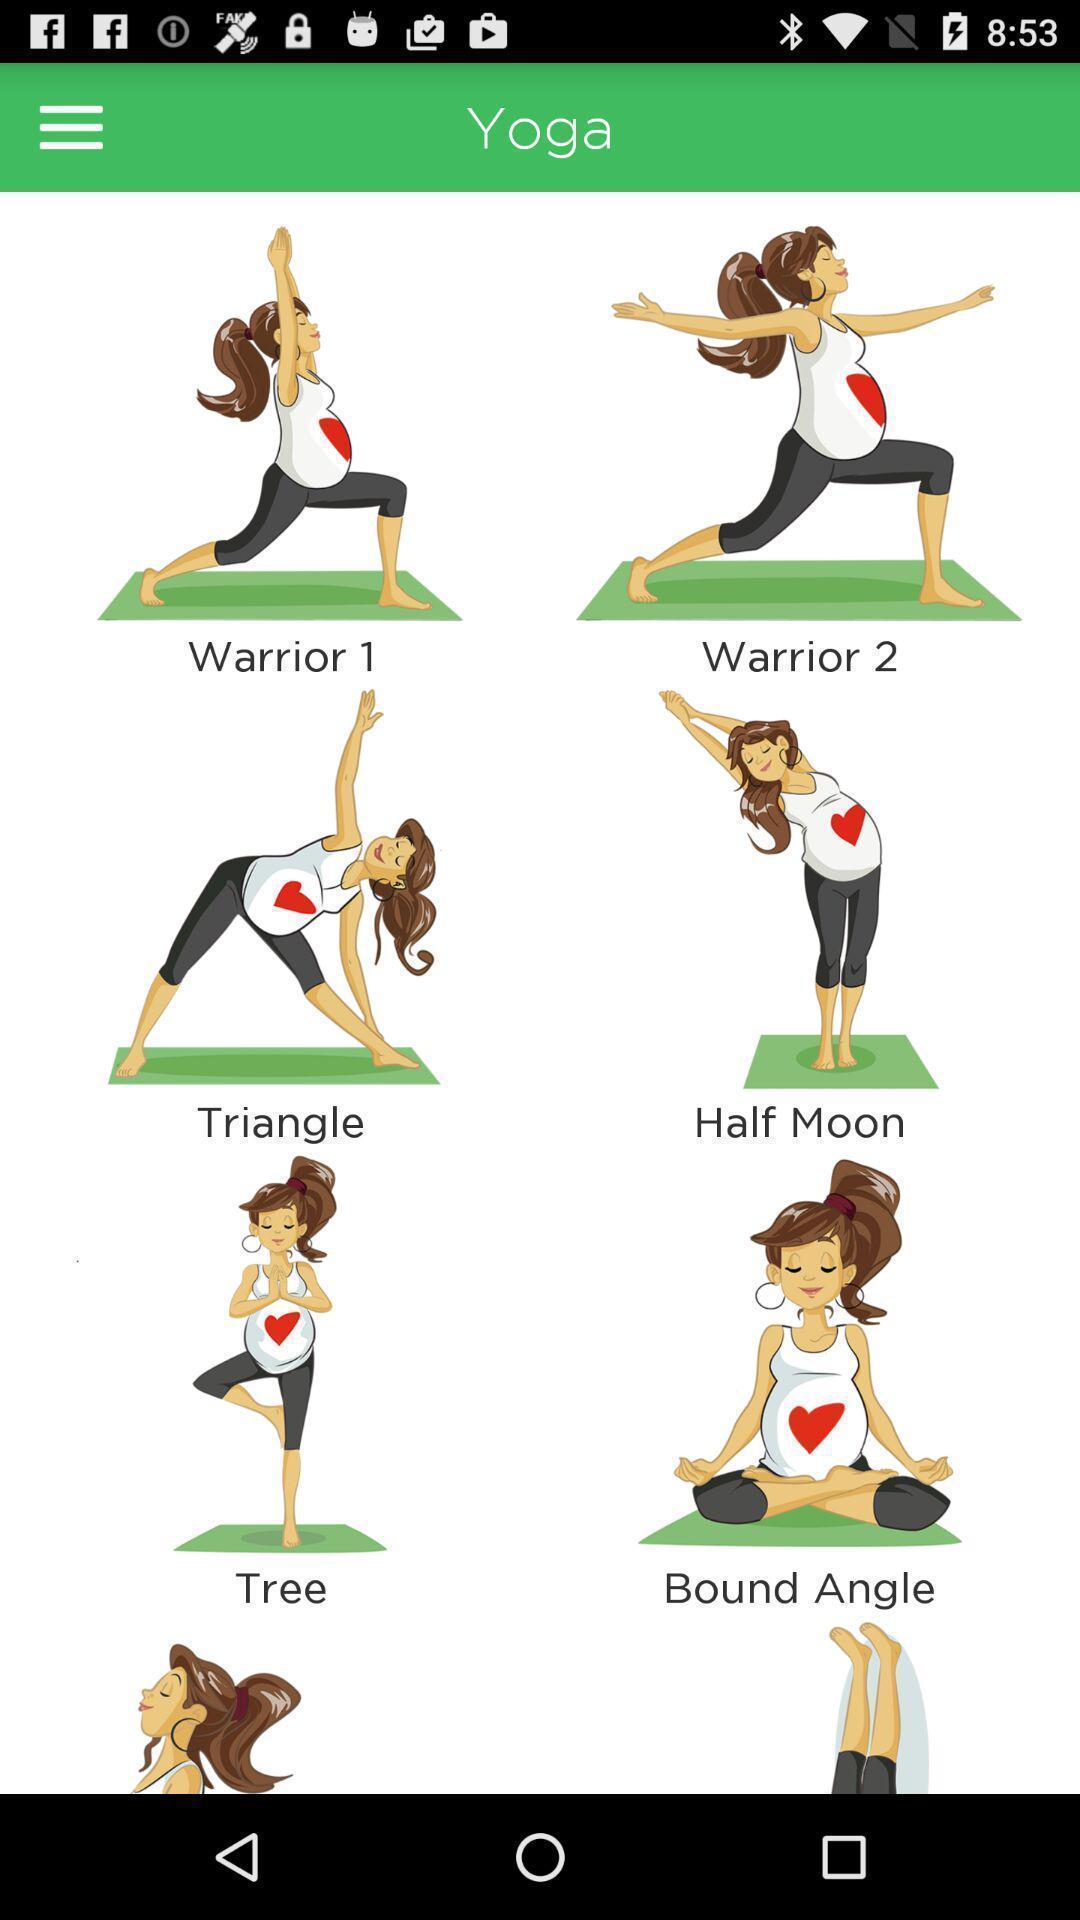Explain what's happening in this screen capture. Screen shows different yoga postures in period tracking application. 